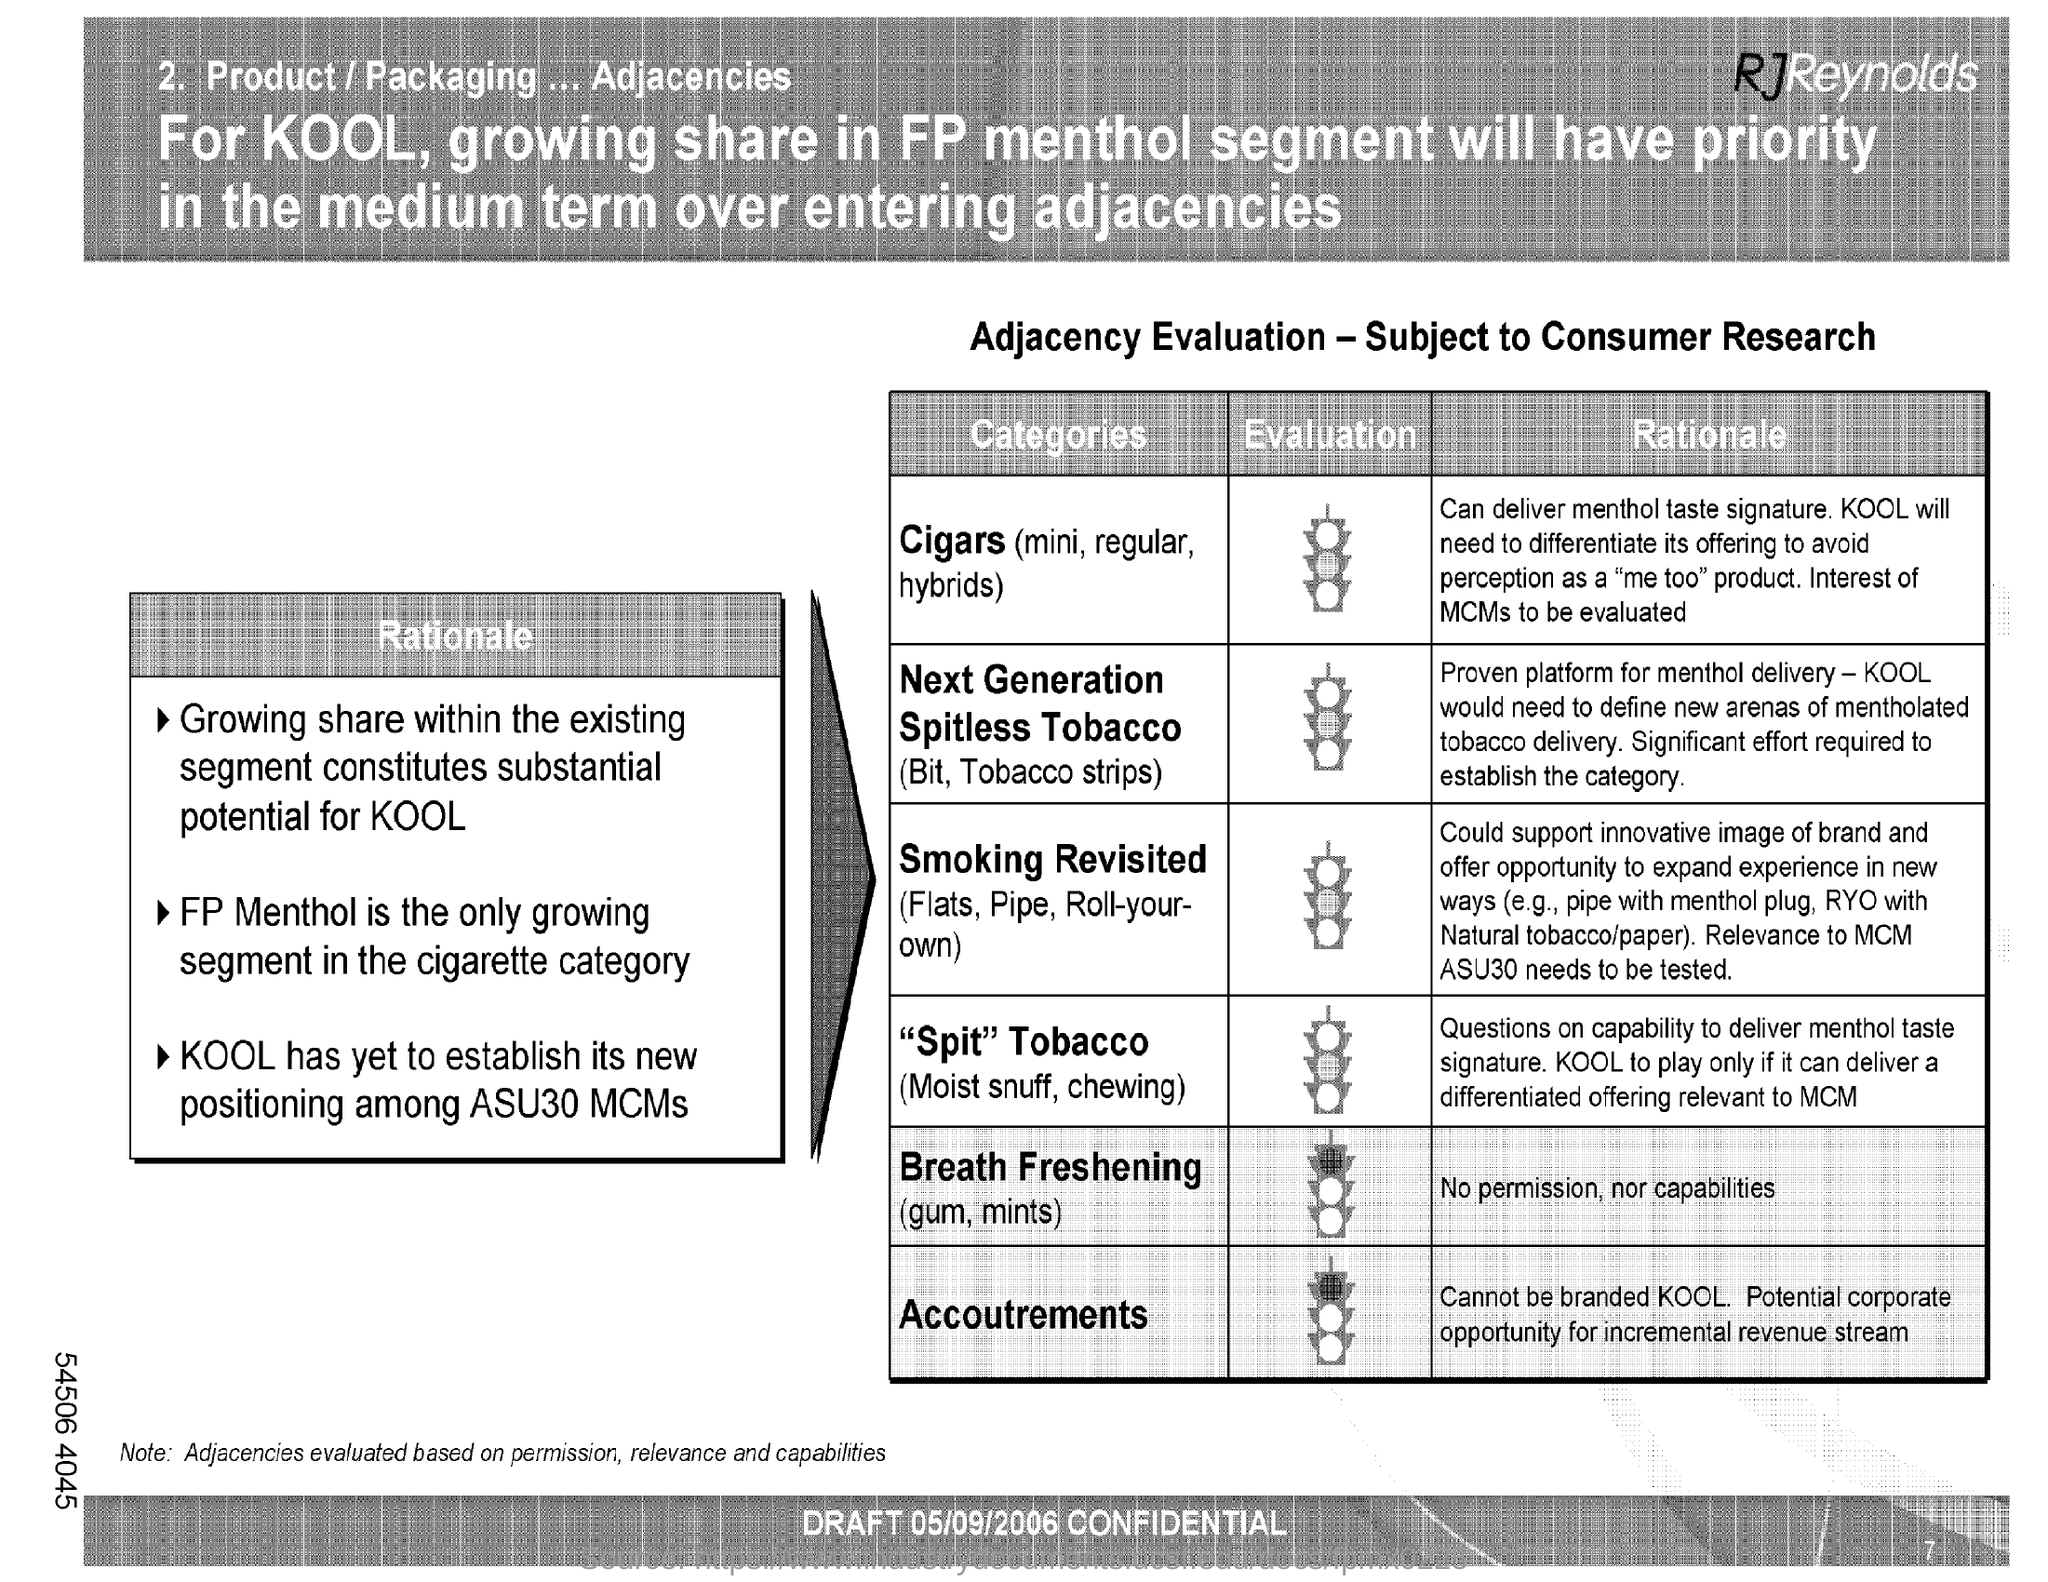Identify some key points in this picture. The draft was dated on May 9, 2006. 